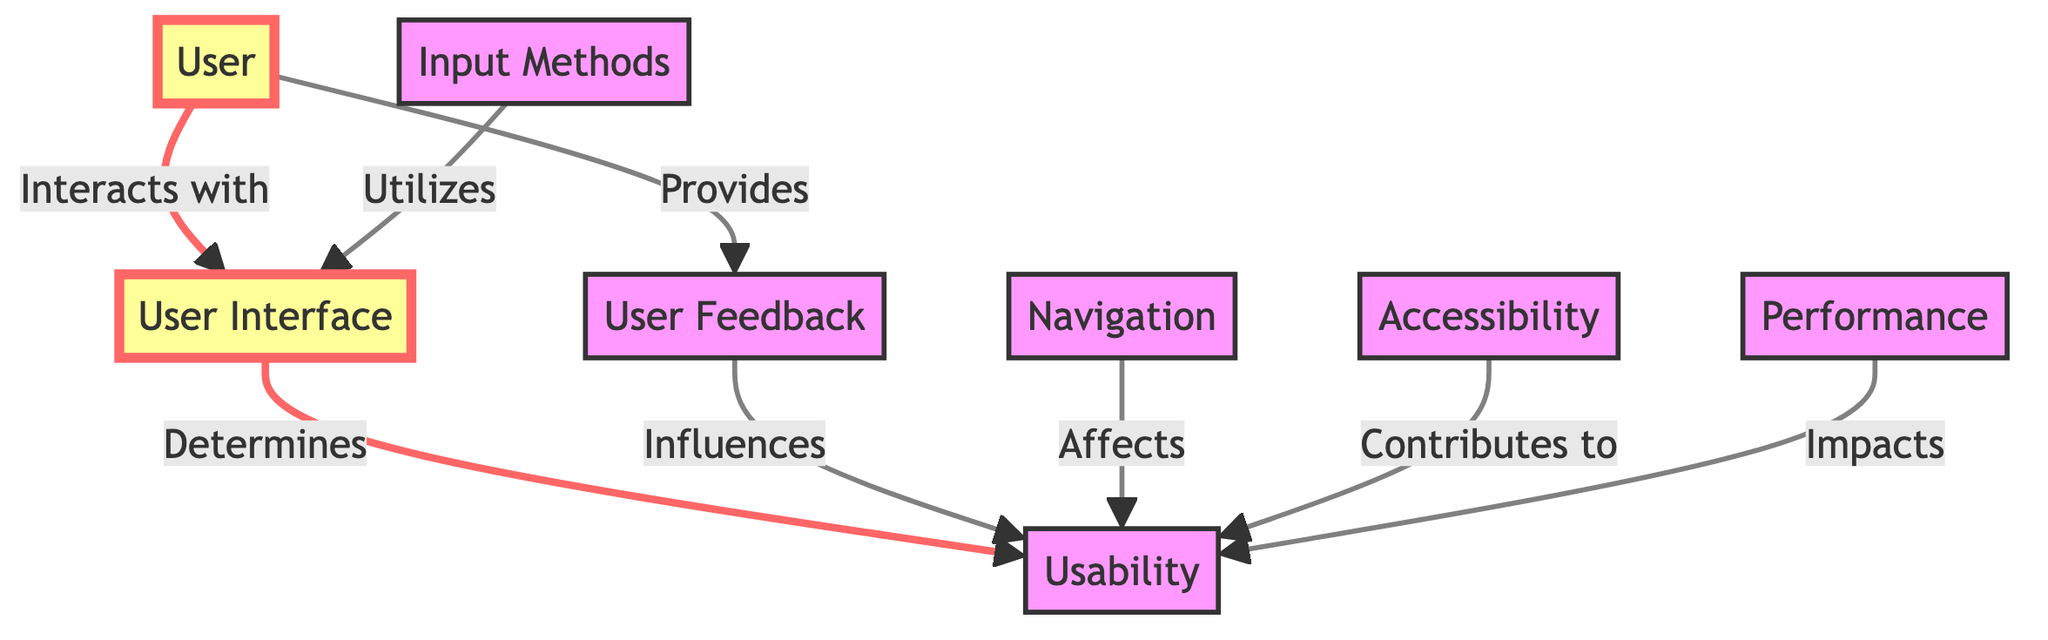What is the main focus of the user in this diagram? The main focus of the user in the diagram is the "User Interface" as it is the element they interact with. The user arrow points directly to the User Interface node.
Answer: User Interface How many relationships are represented in this diagram? By counting the arrows connecting the nodes, there are a total of seven relationships shown, indicating the influence and connections between users, the interface, usability, feedback, navigation, accessibility, and performance.
Answer: Seven Which node directly influences usability? Both "User Feedback" and "Navigation" contribute to usability according to the connections in the diagram. "User Feedback" is explicitly shown as influencing usability.
Answer: User Feedback What element does "Accessibility" contribute to? The diagram clearly indicates that "Accessibility" contributes to the node labeled "Usability", directly mentioning its role in the relationships presented.
Answer: Usability How does the "User" perceive the interface? The diagram illustrates that the "User" interacts with the "User Interface" which, in turn, determines the "Usability" of the application, indicating a direct perception and usage experience.
Answer: Interacts 